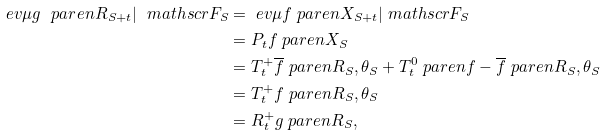Convert formula to latex. <formula><loc_0><loc_0><loc_500><loc_500>\ e v { \mu } { g \ p a r e n { R _ { S + t } } | \ m a t h s c r { F } _ { S } } & = \ e v { \mu } { f \ p a r e n { X _ { S + t } } | \ m a t h s c r { F } _ { S } } \\ & = P _ { t } f \ p a r e n { X _ { S } } \\ & = T _ { t } ^ { + } \overline { f } \ p a r e n { R _ { S } , \theta _ { S } } + T _ { t } ^ { 0 } \ p a r e n { f - \overline { f } } \ p a r e n { R _ { S } , \theta _ { S } } \\ & = T _ { t } ^ { + } f \ p a r e n { R _ { S } , \theta _ { S } } \\ & = R _ { t } ^ { + } g \ p a r e n { R _ { S } } ,</formula> 